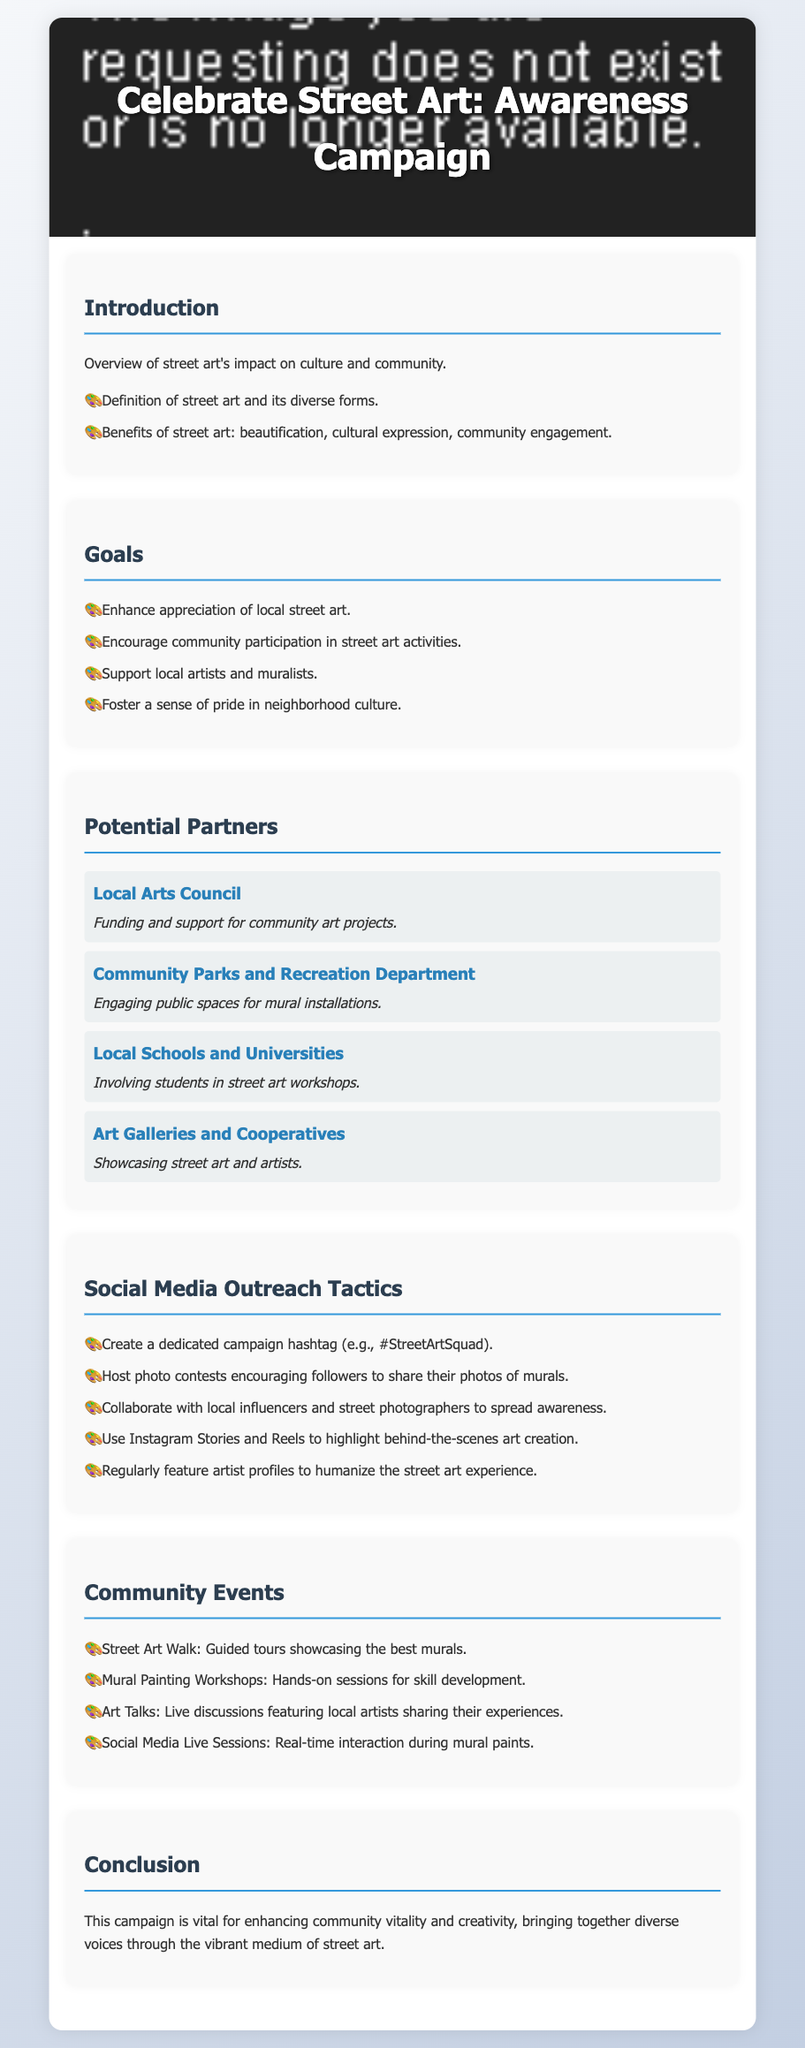What is the title of the campaign? The title is the primary heading of the document that summarizes the campaign's purpose.
Answer: Celebrate Street Art: Awareness Campaign What is one of the goals of the campaign? The goals section lists multiple aims of the campaign, including enhancing appreciation and encouraging participation.
Answer: Enhance appreciation of local street art Who is a potential partner that provides funding and support? The partners section includes various organizations, and one of them is noted for funding community art projects.
Answer: Local Arts Council What type of community event involves guided tours? The events section details various activities planned for the campaign, including one that describes guided tours of murals.
Answer: Street Art Walk What is a tactic for social media outreach mentioned in the document? The social media outreach tactics section contains various strategies, including one designed to engage followers through a dedicated hashtag.
Answer: Create a dedicated campaign hashtag (e.g., #StreetArtSquad) Which department engages public spaces for mural installations? The partner section mentions organizations involved, where one specifically engages public spaces for artistic installations.
Answer: Community Parks and Recreation Department How many types of community events are listed in the document? The community events section enumerates various activities planned, providing a clear count of these event types.
Answer: Four What is featured regularly to humanize the street art experience? The social media outreach section highlights a specific strategy aimed at showcasing individual creators in the community.
Answer: Artist profiles What is the essence of the campaign's conclusion? The conclusion conveys the overall benefit and intention of the campaign towards community engagement through street art.
Answer: Enhancing community vitality and creativity 